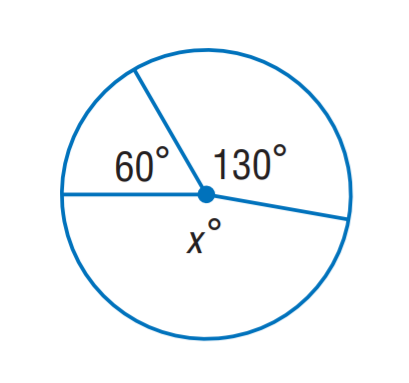Question: Find x.
Choices:
A. 130
B. 150
C. 170
D. 190
Answer with the letter. Answer: C 